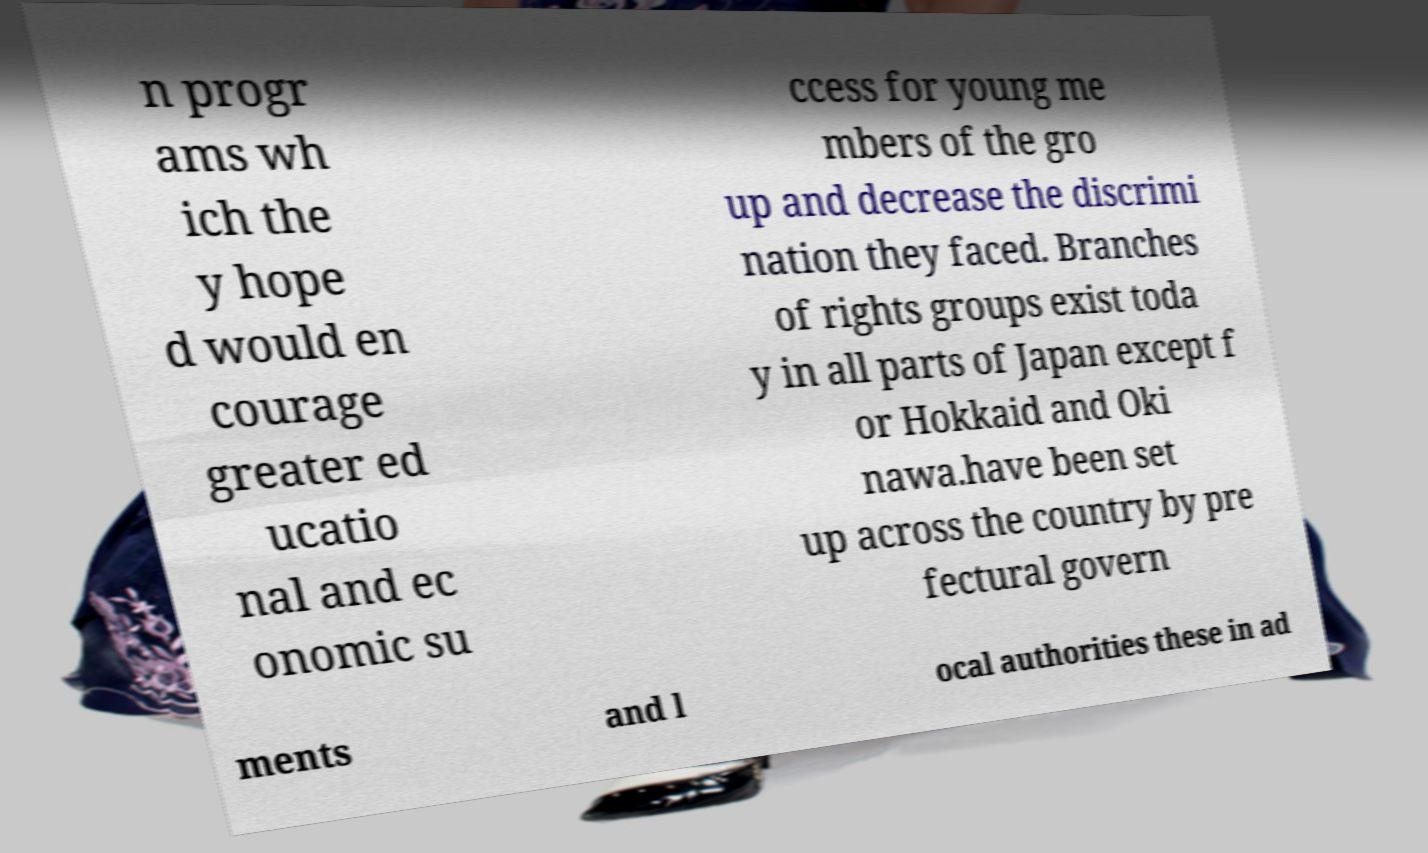For documentation purposes, I need the text within this image transcribed. Could you provide that? n progr ams wh ich the y hope d would en courage greater ed ucatio nal and ec onomic su ccess for young me mbers of the gro up and decrease the discrimi nation they faced. Branches of rights groups exist toda y in all parts of Japan except f or Hokkaid and Oki nawa.have been set up across the country by pre fectural govern ments and l ocal authorities these in ad 